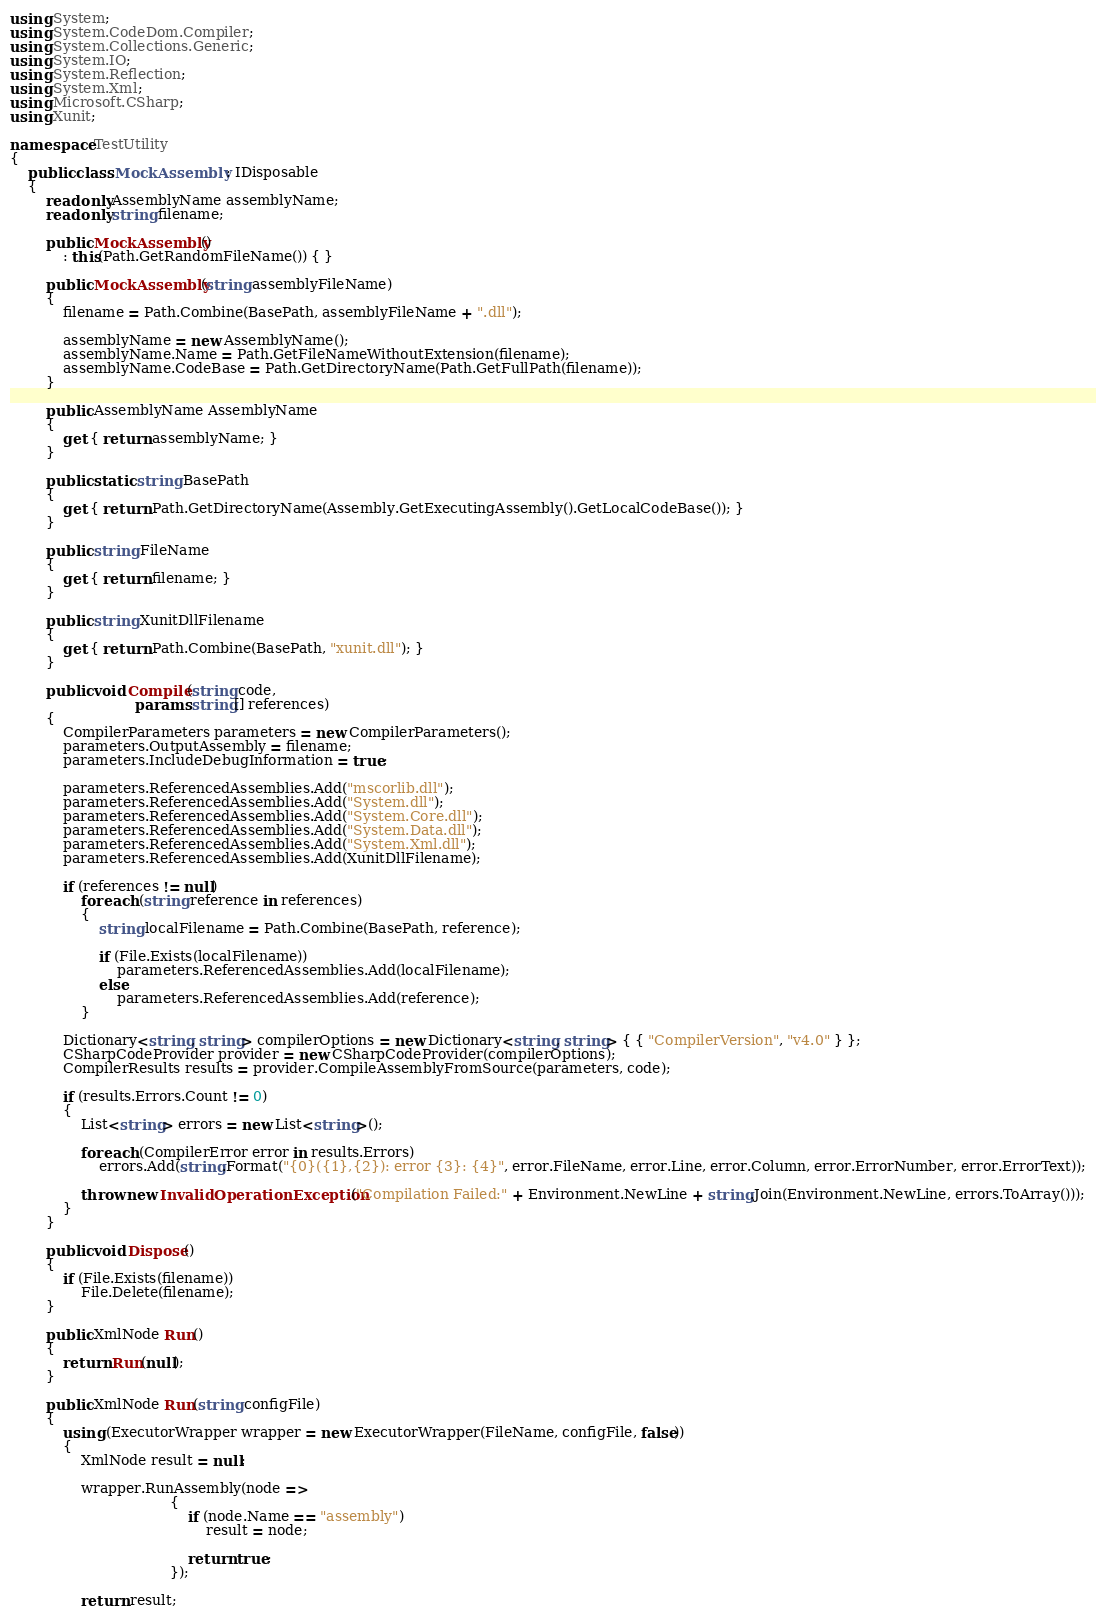Convert code to text. <code><loc_0><loc_0><loc_500><loc_500><_C#_>using System;
using System.CodeDom.Compiler;
using System.Collections.Generic;
using System.IO;
using System.Reflection;
using System.Xml;
using Microsoft.CSharp;
using Xunit;

namespace TestUtility
{
    public class MockAssembly : IDisposable
    {
        readonly AssemblyName assemblyName;
        readonly string filename;

        public MockAssembly()
            : this(Path.GetRandomFileName()) { }

        public MockAssembly(string assemblyFileName)
        {
            filename = Path.Combine(BasePath, assemblyFileName + ".dll");

            assemblyName = new AssemblyName();
            assemblyName.Name = Path.GetFileNameWithoutExtension(filename);
            assemblyName.CodeBase = Path.GetDirectoryName(Path.GetFullPath(filename));
        }

        public AssemblyName AssemblyName
        {
            get { return assemblyName; }
        }

        public static string BasePath
        {
            get { return Path.GetDirectoryName(Assembly.GetExecutingAssembly().GetLocalCodeBase()); }
        }

        public string FileName
        {
            get { return filename; }
        }

        public string XunitDllFilename
        {
            get { return Path.Combine(BasePath, "xunit.dll"); }
        }

        public void Compile(string code,
                            params string[] references)
        {
            CompilerParameters parameters = new CompilerParameters();
            parameters.OutputAssembly = filename;
            parameters.IncludeDebugInformation = true;

            parameters.ReferencedAssemblies.Add("mscorlib.dll");
            parameters.ReferencedAssemblies.Add("System.dll");
            parameters.ReferencedAssemblies.Add("System.Core.dll");
            parameters.ReferencedAssemblies.Add("System.Data.dll");
            parameters.ReferencedAssemblies.Add("System.Xml.dll");
            parameters.ReferencedAssemblies.Add(XunitDllFilename);

            if (references != null)
                foreach (string reference in references)
                {
                    string localFilename = Path.Combine(BasePath, reference);

                    if (File.Exists(localFilename))
                        parameters.ReferencedAssemblies.Add(localFilename);
                    else
                        parameters.ReferencedAssemblies.Add(reference);
                }

            Dictionary<string, string> compilerOptions = new Dictionary<string, string> { { "CompilerVersion", "v4.0" } };
            CSharpCodeProvider provider = new CSharpCodeProvider(compilerOptions);
            CompilerResults results = provider.CompileAssemblyFromSource(parameters, code);

            if (results.Errors.Count != 0)
            {
                List<string> errors = new List<string>();

                foreach (CompilerError error in results.Errors)
                    errors.Add(string.Format("{0}({1},{2}): error {3}: {4}", error.FileName, error.Line, error.Column, error.ErrorNumber, error.ErrorText));

                throw new InvalidOperationException("Compilation Failed:" + Environment.NewLine + string.Join(Environment.NewLine, errors.ToArray()));
            }
        }

        public void Dispose()
        {
            if (File.Exists(filename))
                File.Delete(filename);
        }

        public XmlNode Run()
        {
            return Run(null);
        }

        public XmlNode Run(string configFile)
        {
            using (ExecutorWrapper wrapper = new ExecutorWrapper(FileName, configFile, false))
            {
                XmlNode result = null;

                wrapper.RunAssembly(node =>
                                    {
                                        if (node.Name == "assembly")
                                            result = node;

                                        return true;
                                    });

                return result;</code> 